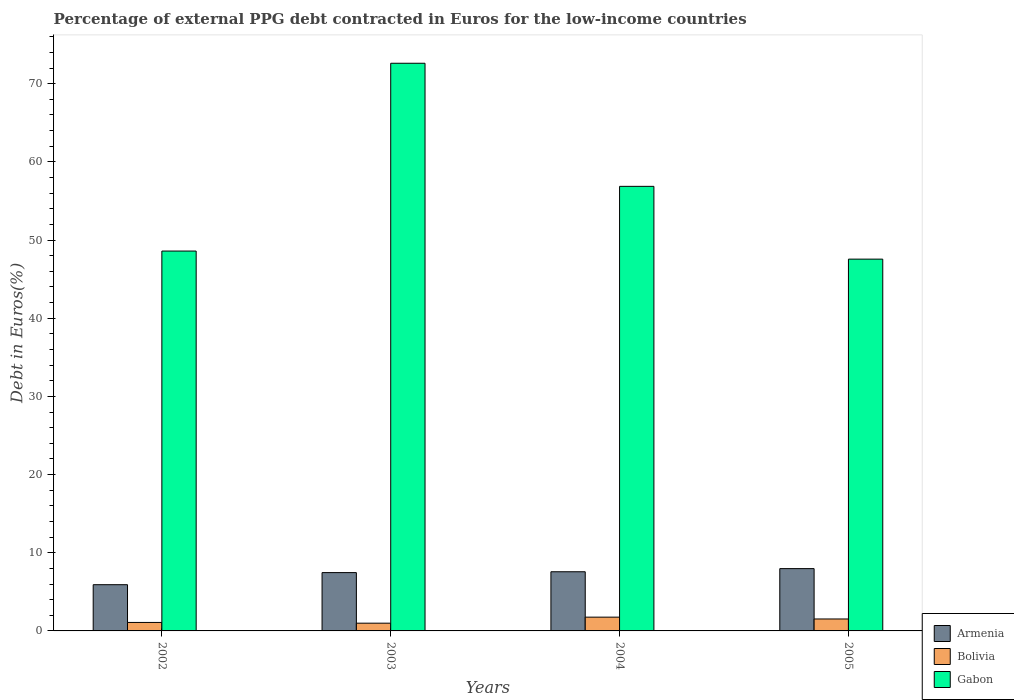How many groups of bars are there?
Your answer should be compact. 4. Are the number of bars per tick equal to the number of legend labels?
Provide a succinct answer. Yes. Are the number of bars on each tick of the X-axis equal?
Offer a very short reply. Yes. How many bars are there on the 2nd tick from the left?
Your answer should be compact. 3. How many bars are there on the 4th tick from the right?
Provide a succinct answer. 3. What is the percentage of external PPG debt contracted in Euros in Bolivia in 2002?
Your response must be concise. 1.08. Across all years, what is the maximum percentage of external PPG debt contracted in Euros in Armenia?
Give a very brief answer. 7.97. Across all years, what is the minimum percentage of external PPG debt contracted in Euros in Gabon?
Make the answer very short. 47.55. In which year was the percentage of external PPG debt contracted in Euros in Gabon maximum?
Your answer should be compact. 2003. What is the total percentage of external PPG debt contracted in Euros in Gabon in the graph?
Your response must be concise. 225.61. What is the difference between the percentage of external PPG debt contracted in Euros in Armenia in 2004 and that in 2005?
Give a very brief answer. -0.4. What is the difference between the percentage of external PPG debt contracted in Euros in Gabon in 2003 and the percentage of external PPG debt contracted in Euros in Armenia in 2002?
Your answer should be compact. 66.69. What is the average percentage of external PPG debt contracted in Euros in Gabon per year?
Offer a very short reply. 56.4. In the year 2002, what is the difference between the percentage of external PPG debt contracted in Euros in Gabon and percentage of external PPG debt contracted in Euros in Bolivia?
Provide a short and direct response. 47.5. In how many years, is the percentage of external PPG debt contracted in Euros in Bolivia greater than 16 %?
Give a very brief answer. 0. What is the ratio of the percentage of external PPG debt contracted in Euros in Gabon in 2002 to that in 2003?
Offer a terse response. 0.67. What is the difference between the highest and the second highest percentage of external PPG debt contracted in Euros in Armenia?
Offer a very short reply. 0.4. What is the difference between the highest and the lowest percentage of external PPG debt contracted in Euros in Gabon?
Provide a succinct answer. 25.05. Is the sum of the percentage of external PPG debt contracted in Euros in Armenia in 2003 and 2004 greater than the maximum percentage of external PPG debt contracted in Euros in Gabon across all years?
Offer a very short reply. No. What does the 3rd bar from the left in 2005 represents?
Your answer should be very brief. Gabon. What does the 2nd bar from the right in 2005 represents?
Keep it short and to the point. Bolivia. Is it the case that in every year, the sum of the percentage of external PPG debt contracted in Euros in Bolivia and percentage of external PPG debt contracted in Euros in Armenia is greater than the percentage of external PPG debt contracted in Euros in Gabon?
Give a very brief answer. No. Are all the bars in the graph horizontal?
Ensure brevity in your answer.  No. How many years are there in the graph?
Provide a succinct answer. 4. Does the graph contain any zero values?
Your response must be concise. No. How are the legend labels stacked?
Ensure brevity in your answer.  Vertical. What is the title of the graph?
Your answer should be compact. Percentage of external PPG debt contracted in Euros for the low-income countries. Does "Botswana" appear as one of the legend labels in the graph?
Your answer should be compact. No. What is the label or title of the Y-axis?
Your answer should be compact. Debt in Euros(%). What is the Debt in Euros(%) of Armenia in 2002?
Provide a succinct answer. 5.91. What is the Debt in Euros(%) of Bolivia in 2002?
Give a very brief answer. 1.08. What is the Debt in Euros(%) in Gabon in 2002?
Provide a short and direct response. 48.59. What is the Debt in Euros(%) of Armenia in 2003?
Your answer should be compact. 7.46. What is the Debt in Euros(%) of Bolivia in 2003?
Keep it short and to the point. 0.99. What is the Debt in Euros(%) of Gabon in 2003?
Provide a succinct answer. 72.61. What is the Debt in Euros(%) of Armenia in 2004?
Offer a terse response. 7.57. What is the Debt in Euros(%) of Bolivia in 2004?
Keep it short and to the point. 1.76. What is the Debt in Euros(%) of Gabon in 2004?
Offer a terse response. 56.86. What is the Debt in Euros(%) of Armenia in 2005?
Your response must be concise. 7.97. What is the Debt in Euros(%) in Bolivia in 2005?
Offer a very short reply. 1.53. What is the Debt in Euros(%) of Gabon in 2005?
Offer a terse response. 47.55. Across all years, what is the maximum Debt in Euros(%) of Armenia?
Keep it short and to the point. 7.97. Across all years, what is the maximum Debt in Euros(%) in Bolivia?
Your answer should be compact. 1.76. Across all years, what is the maximum Debt in Euros(%) in Gabon?
Your response must be concise. 72.61. Across all years, what is the minimum Debt in Euros(%) of Armenia?
Your answer should be very brief. 5.91. Across all years, what is the minimum Debt in Euros(%) in Gabon?
Provide a short and direct response. 47.55. What is the total Debt in Euros(%) of Armenia in the graph?
Your answer should be compact. 28.91. What is the total Debt in Euros(%) of Bolivia in the graph?
Provide a succinct answer. 5.36. What is the total Debt in Euros(%) of Gabon in the graph?
Your answer should be compact. 225.61. What is the difference between the Debt in Euros(%) of Armenia in 2002 and that in 2003?
Keep it short and to the point. -1.55. What is the difference between the Debt in Euros(%) of Bolivia in 2002 and that in 2003?
Your response must be concise. 0.09. What is the difference between the Debt in Euros(%) of Gabon in 2002 and that in 2003?
Offer a terse response. -24.02. What is the difference between the Debt in Euros(%) in Armenia in 2002 and that in 2004?
Provide a succinct answer. -1.66. What is the difference between the Debt in Euros(%) in Bolivia in 2002 and that in 2004?
Offer a very short reply. -0.68. What is the difference between the Debt in Euros(%) in Gabon in 2002 and that in 2004?
Offer a terse response. -8.28. What is the difference between the Debt in Euros(%) of Armenia in 2002 and that in 2005?
Provide a succinct answer. -2.06. What is the difference between the Debt in Euros(%) of Bolivia in 2002 and that in 2005?
Your response must be concise. -0.44. What is the difference between the Debt in Euros(%) of Gabon in 2002 and that in 2005?
Ensure brevity in your answer.  1.03. What is the difference between the Debt in Euros(%) in Armenia in 2003 and that in 2004?
Offer a very short reply. -0.11. What is the difference between the Debt in Euros(%) of Bolivia in 2003 and that in 2004?
Offer a terse response. -0.77. What is the difference between the Debt in Euros(%) of Gabon in 2003 and that in 2004?
Offer a very short reply. 15.74. What is the difference between the Debt in Euros(%) in Armenia in 2003 and that in 2005?
Your response must be concise. -0.51. What is the difference between the Debt in Euros(%) in Bolivia in 2003 and that in 2005?
Provide a succinct answer. -0.54. What is the difference between the Debt in Euros(%) of Gabon in 2003 and that in 2005?
Provide a succinct answer. 25.05. What is the difference between the Debt in Euros(%) in Armenia in 2004 and that in 2005?
Your answer should be compact. -0.4. What is the difference between the Debt in Euros(%) of Bolivia in 2004 and that in 2005?
Offer a terse response. 0.23. What is the difference between the Debt in Euros(%) of Gabon in 2004 and that in 2005?
Provide a succinct answer. 9.31. What is the difference between the Debt in Euros(%) in Armenia in 2002 and the Debt in Euros(%) in Bolivia in 2003?
Your answer should be compact. 4.92. What is the difference between the Debt in Euros(%) in Armenia in 2002 and the Debt in Euros(%) in Gabon in 2003?
Provide a succinct answer. -66.69. What is the difference between the Debt in Euros(%) of Bolivia in 2002 and the Debt in Euros(%) of Gabon in 2003?
Make the answer very short. -71.52. What is the difference between the Debt in Euros(%) in Armenia in 2002 and the Debt in Euros(%) in Bolivia in 2004?
Provide a succinct answer. 4.15. What is the difference between the Debt in Euros(%) of Armenia in 2002 and the Debt in Euros(%) of Gabon in 2004?
Your response must be concise. -50.95. What is the difference between the Debt in Euros(%) in Bolivia in 2002 and the Debt in Euros(%) in Gabon in 2004?
Provide a succinct answer. -55.78. What is the difference between the Debt in Euros(%) in Armenia in 2002 and the Debt in Euros(%) in Bolivia in 2005?
Offer a very short reply. 4.38. What is the difference between the Debt in Euros(%) in Armenia in 2002 and the Debt in Euros(%) in Gabon in 2005?
Your answer should be very brief. -41.64. What is the difference between the Debt in Euros(%) in Bolivia in 2002 and the Debt in Euros(%) in Gabon in 2005?
Keep it short and to the point. -46.47. What is the difference between the Debt in Euros(%) in Armenia in 2003 and the Debt in Euros(%) in Bolivia in 2004?
Your answer should be compact. 5.7. What is the difference between the Debt in Euros(%) of Armenia in 2003 and the Debt in Euros(%) of Gabon in 2004?
Your response must be concise. -49.4. What is the difference between the Debt in Euros(%) in Bolivia in 2003 and the Debt in Euros(%) in Gabon in 2004?
Your response must be concise. -55.87. What is the difference between the Debt in Euros(%) of Armenia in 2003 and the Debt in Euros(%) of Bolivia in 2005?
Your answer should be very brief. 5.93. What is the difference between the Debt in Euros(%) of Armenia in 2003 and the Debt in Euros(%) of Gabon in 2005?
Your answer should be very brief. -40.09. What is the difference between the Debt in Euros(%) of Bolivia in 2003 and the Debt in Euros(%) of Gabon in 2005?
Provide a short and direct response. -46.56. What is the difference between the Debt in Euros(%) of Armenia in 2004 and the Debt in Euros(%) of Bolivia in 2005?
Your response must be concise. 6.04. What is the difference between the Debt in Euros(%) of Armenia in 2004 and the Debt in Euros(%) of Gabon in 2005?
Your answer should be very brief. -39.99. What is the difference between the Debt in Euros(%) in Bolivia in 2004 and the Debt in Euros(%) in Gabon in 2005?
Your response must be concise. -45.79. What is the average Debt in Euros(%) in Armenia per year?
Your answer should be very brief. 7.23. What is the average Debt in Euros(%) in Bolivia per year?
Offer a terse response. 1.34. What is the average Debt in Euros(%) of Gabon per year?
Your answer should be compact. 56.4. In the year 2002, what is the difference between the Debt in Euros(%) in Armenia and Debt in Euros(%) in Bolivia?
Provide a succinct answer. 4.83. In the year 2002, what is the difference between the Debt in Euros(%) of Armenia and Debt in Euros(%) of Gabon?
Ensure brevity in your answer.  -42.67. In the year 2002, what is the difference between the Debt in Euros(%) of Bolivia and Debt in Euros(%) of Gabon?
Your answer should be compact. -47.5. In the year 2003, what is the difference between the Debt in Euros(%) in Armenia and Debt in Euros(%) in Bolivia?
Provide a succinct answer. 6.47. In the year 2003, what is the difference between the Debt in Euros(%) in Armenia and Debt in Euros(%) in Gabon?
Your answer should be compact. -65.15. In the year 2003, what is the difference between the Debt in Euros(%) of Bolivia and Debt in Euros(%) of Gabon?
Provide a succinct answer. -71.62. In the year 2004, what is the difference between the Debt in Euros(%) of Armenia and Debt in Euros(%) of Bolivia?
Your answer should be very brief. 5.81. In the year 2004, what is the difference between the Debt in Euros(%) in Armenia and Debt in Euros(%) in Gabon?
Provide a succinct answer. -49.3. In the year 2004, what is the difference between the Debt in Euros(%) in Bolivia and Debt in Euros(%) in Gabon?
Offer a terse response. -55.1. In the year 2005, what is the difference between the Debt in Euros(%) of Armenia and Debt in Euros(%) of Bolivia?
Your answer should be compact. 6.44. In the year 2005, what is the difference between the Debt in Euros(%) of Armenia and Debt in Euros(%) of Gabon?
Provide a short and direct response. -39.58. In the year 2005, what is the difference between the Debt in Euros(%) in Bolivia and Debt in Euros(%) in Gabon?
Provide a short and direct response. -46.03. What is the ratio of the Debt in Euros(%) in Armenia in 2002 to that in 2003?
Your answer should be compact. 0.79. What is the ratio of the Debt in Euros(%) of Bolivia in 2002 to that in 2003?
Your answer should be compact. 1.1. What is the ratio of the Debt in Euros(%) in Gabon in 2002 to that in 2003?
Offer a very short reply. 0.67. What is the ratio of the Debt in Euros(%) in Armenia in 2002 to that in 2004?
Give a very brief answer. 0.78. What is the ratio of the Debt in Euros(%) in Bolivia in 2002 to that in 2004?
Your response must be concise. 0.62. What is the ratio of the Debt in Euros(%) in Gabon in 2002 to that in 2004?
Offer a very short reply. 0.85. What is the ratio of the Debt in Euros(%) in Armenia in 2002 to that in 2005?
Ensure brevity in your answer.  0.74. What is the ratio of the Debt in Euros(%) in Bolivia in 2002 to that in 2005?
Offer a terse response. 0.71. What is the ratio of the Debt in Euros(%) of Gabon in 2002 to that in 2005?
Provide a succinct answer. 1.02. What is the ratio of the Debt in Euros(%) in Armenia in 2003 to that in 2004?
Make the answer very short. 0.99. What is the ratio of the Debt in Euros(%) of Bolivia in 2003 to that in 2004?
Make the answer very short. 0.56. What is the ratio of the Debt in Euros(%) of Gabon in 2003 to that in 2004?
Your answer should be very brief. 1.28. What is the ratio of the Debt in Euros(%) in Armenia in 2003 to that in 2005?
Give a very brief answer. 0.94. What is the ratio of the Debt in Euros(%) in Bolivia in 2003 to that in 2005?
Provide a short and direct response. 0.65. What is the ratio of the Debt in Euros(%) in Gabon in 2003 to that in 2005?
Make the answer very short. 1.53. What is the ratio of the Debt in Euros(%) in Armenia in 2004 to that in 2005?
Provide a short and direct response. 0.95. What is the ratio of the Debt in Euros(%) of Bolivia in 2004 to that in 2005?
Your response must be concise. 1.15. What is the ratio of the Debt in Euros(%) in Gabon in 2004 to that in 2005?
Your response must be concise. 1.2. What is the difference between the highest and the second highest Debt in Euros(%) of Armenia?
Provide a short and direct response. 0.4. What is the difference between the highest and the second highest Debt in Euros(%) of Bolivia?
Offer a terse response. 0.23. What is the difference between the highest and the second highest Debt in Euros(%) of Gabon?
Make the answer very short. 15.74. What is the difference between the highest and the lowest Debt in Euros(%) in Armenia?
Your answer should be compact. 2.06. What is the difference between the highest and the lowest Debt in Euros(%) in Bolivia?
Provide a short and direct response. 0.77. What is the difference between the highest and the lowest Debt in Euros(%) in Gabon?
Make the answer very short. 25.05. 